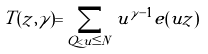Convert formula to latex. <formula><loc_0><loc_0><loc_500><loc_500>T ( z , \gamma ) = \sum _ { Q < u \leq N } u ^ { \gamma - 1 } e ( u z )</formula> 